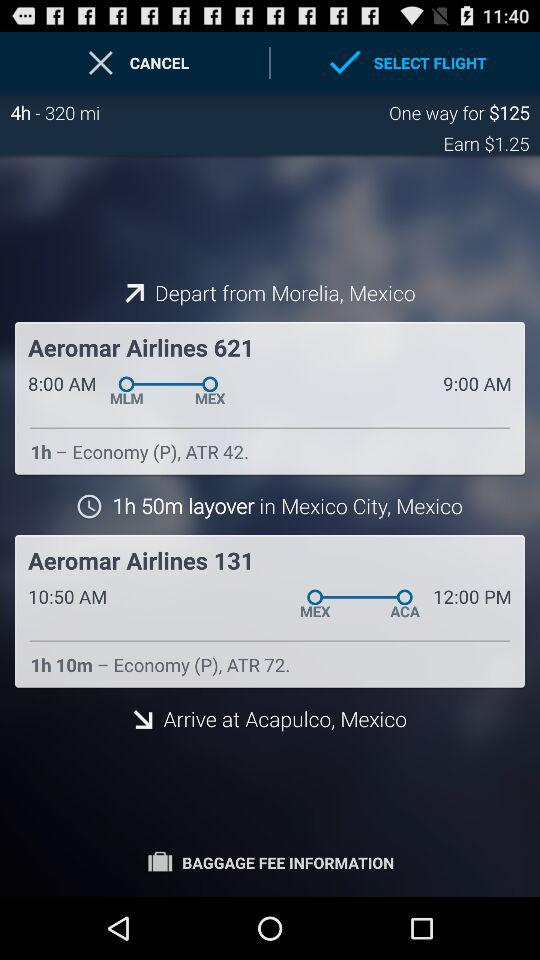What airline is used to travel from Morelia to Mexico City? The airline used to travel from Morelia to Mexico City is "Aeromar Airlines 621". 